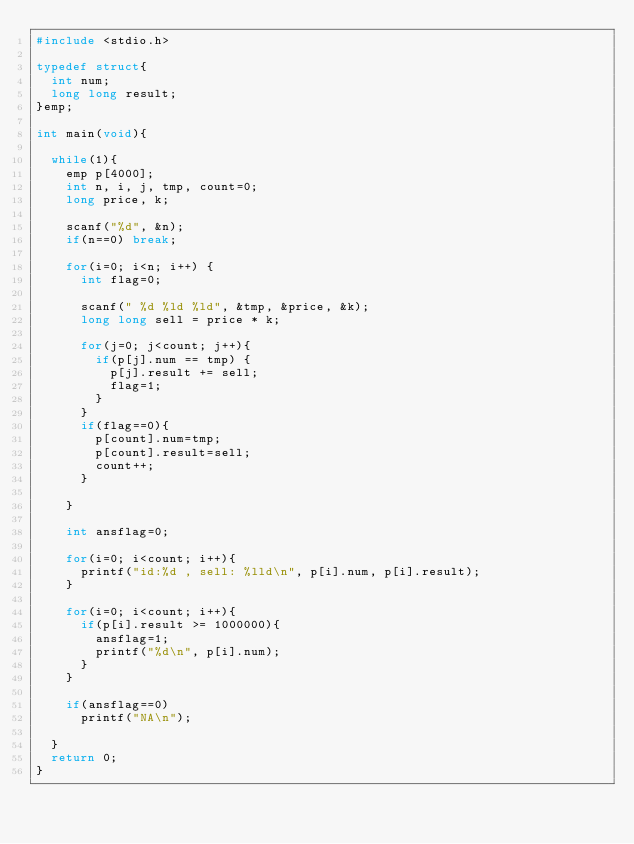Convert code to text. <code><loc_0><loc_0><loc_500><loc_500><_C_>#include <stdio.h>

typedef struct{
	int num;
	long long result;
}emp;

int main(void){

	while(1){
		emp p[4000];
		int n, i, j, tmp, count=0;
		long price, k;
	
		scanf("%d", &n);
		if(n==0) break;
		
		for(i=0; i<n; i++) {
			int flag=0;
	
			scanf(" %d %ld %ld", &tmp, &price, &k);
			long long sell = price * k;
		
			for(j=0; j<count; j++){
				if(p[j].num == tmp) { 
					p[j].result += sell;
					flag=1;	
				}
			}
			if(flag==0){
				p[count].num=tmp;
				p[count].result=sell;
				count++;
			}
			
		}
	
		int ansflag=0;
		
		for(i=0; i<count; i++){
			printf("id:%d , sell: %lld\n", p[i].num, p[i].result);
		} 
	
		for(i=0; i<count; i++){
			if(p[i].result >= 1000000){
				ansflag=1;
				printf("%d\n", p[i].num);
			}
		} 

		if(ansflag==0)
			printf("NA\n");
	
	}
	return 0;
}</code> 